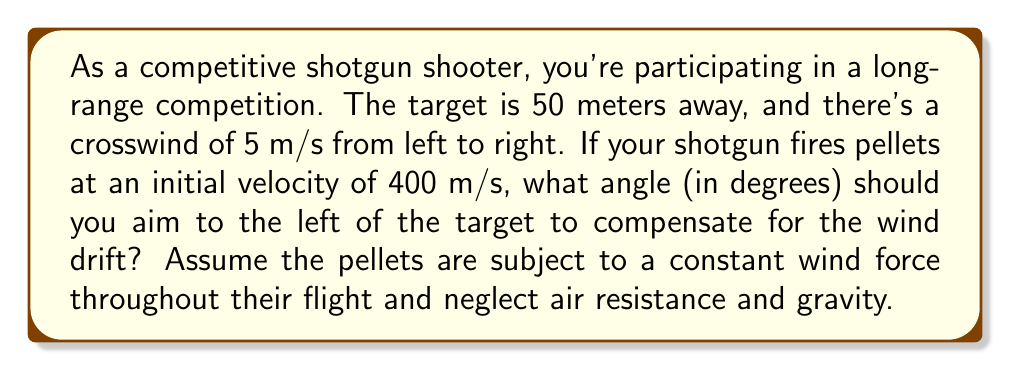Provide a solution to this math problem. To solve this problem, we need to consider the horizontal displacement caused by the wind and determine the angle needed to compensate for it. Let's break it down step by step:

1) First, we need to calculate the time of flight for the pellets:
   $t = \frac{distance}{velocity} = \frac{50 \text{ m}}{400 \text{ m/s}} = 0.125 \text{ s}$

2) The horizontal displacement due to wind can be calculated using the equation:
   $x = \frac{1}{2}at^2$, where $a$ is the acceleration due to wind.

3) The acceleration due to wind can be approximated as:
   $a = \frac{wind \text{ } speed}{time \text{ } of \text{ } flight} = \frac{5 \text{ m/s}}{0.125 \text{ s}} = 40 \text{ m/s}^2$

4) Now we can calculate the horizontal displacement:
   $x = \frac{1}{2}(40 \text{ m/s}^2)(0.125 \text{ s})^2 = 0.3125 \text{ m}$

5) To find the angle, we can use the tangent function:
   $\tan(\theta) = \frac{opposite}{adjacent} = \frac{0.3125 \text{ m}}{50 \text{ m}}$

6) Solving for $\theta$:
   $\theta = \arctan(\frac{0.3125}{50}) \approx 0.3581 \text{ degrees}$

Therefore, you should aim approximately 0.3581 degrees to the left of the target to compensate for the wind drift.
Answer: $\theta \approx 0.3581 \text{ degrees}$ 